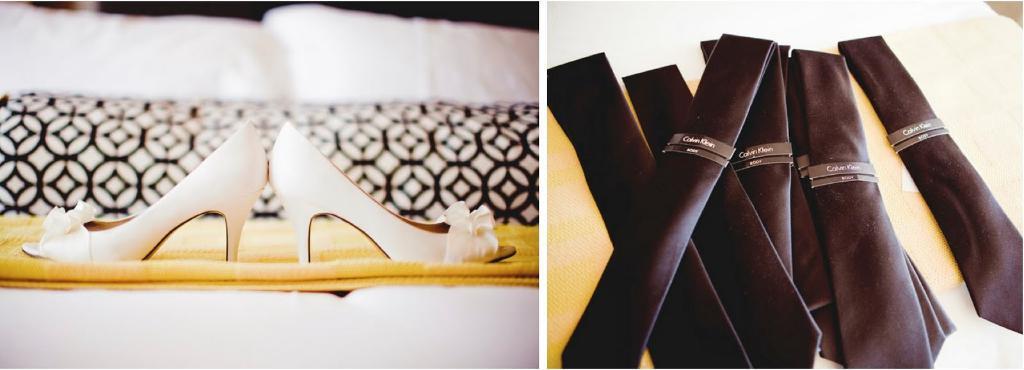Could you give a brief overview of what you see in this image? It is a collage image. On the right side of the image there are ties on the table. On the left side of the image there are heels, cushions on the sofa. 